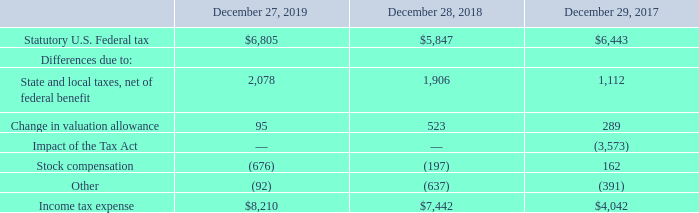Note 12 – Income Taxes
Income tax expense for the fiscal years ended December 27, 2019, December 28, 2018 and December 29, 2017 differed from amounts computed using the statutory federal income tax rate due to the following reasons:
What is the Statutory U.S. Federal tax for 2019, 2018 and 2017 respectively? $6,805, $5,847, $6,443. What is the Income tax expense for 2019, 2018 and 2017 respectively? $8,210, $7,442, $4,042. What is the change in valuation allowance for 2017? 289. Which year has the highest Statutory U.S. Federal tax? 6,805> 6,443> 5,847
Answer: 2019. What is the change in Statutory U.S. Federal tax between 2018 and 2019? 6,805-5,847
Answer: 958. What is the average Statutory U.S. Federal tax from 2017-2019? (6,805+ 5,847+ 6,443)/3
Answer: 6365. 